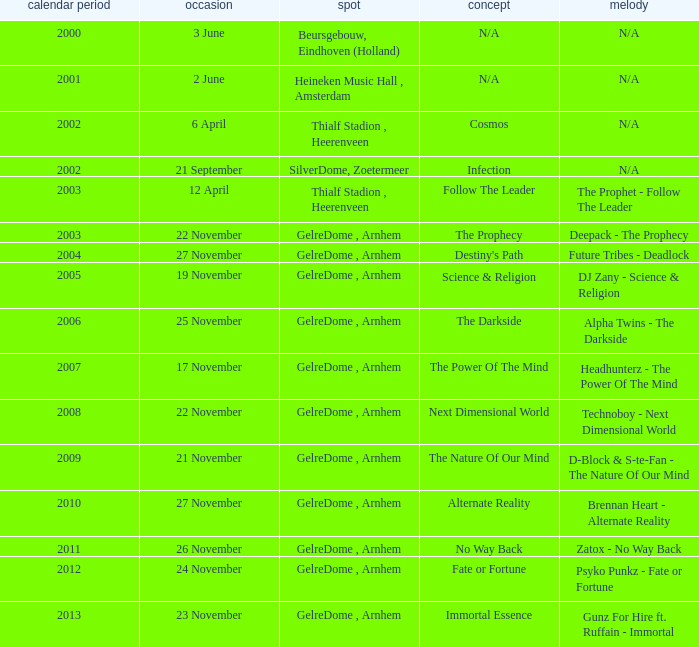What is the earliest year it was located in gelredome, arnhem, and a Anthem of technoboy - next dimensional world? 2008.0. 